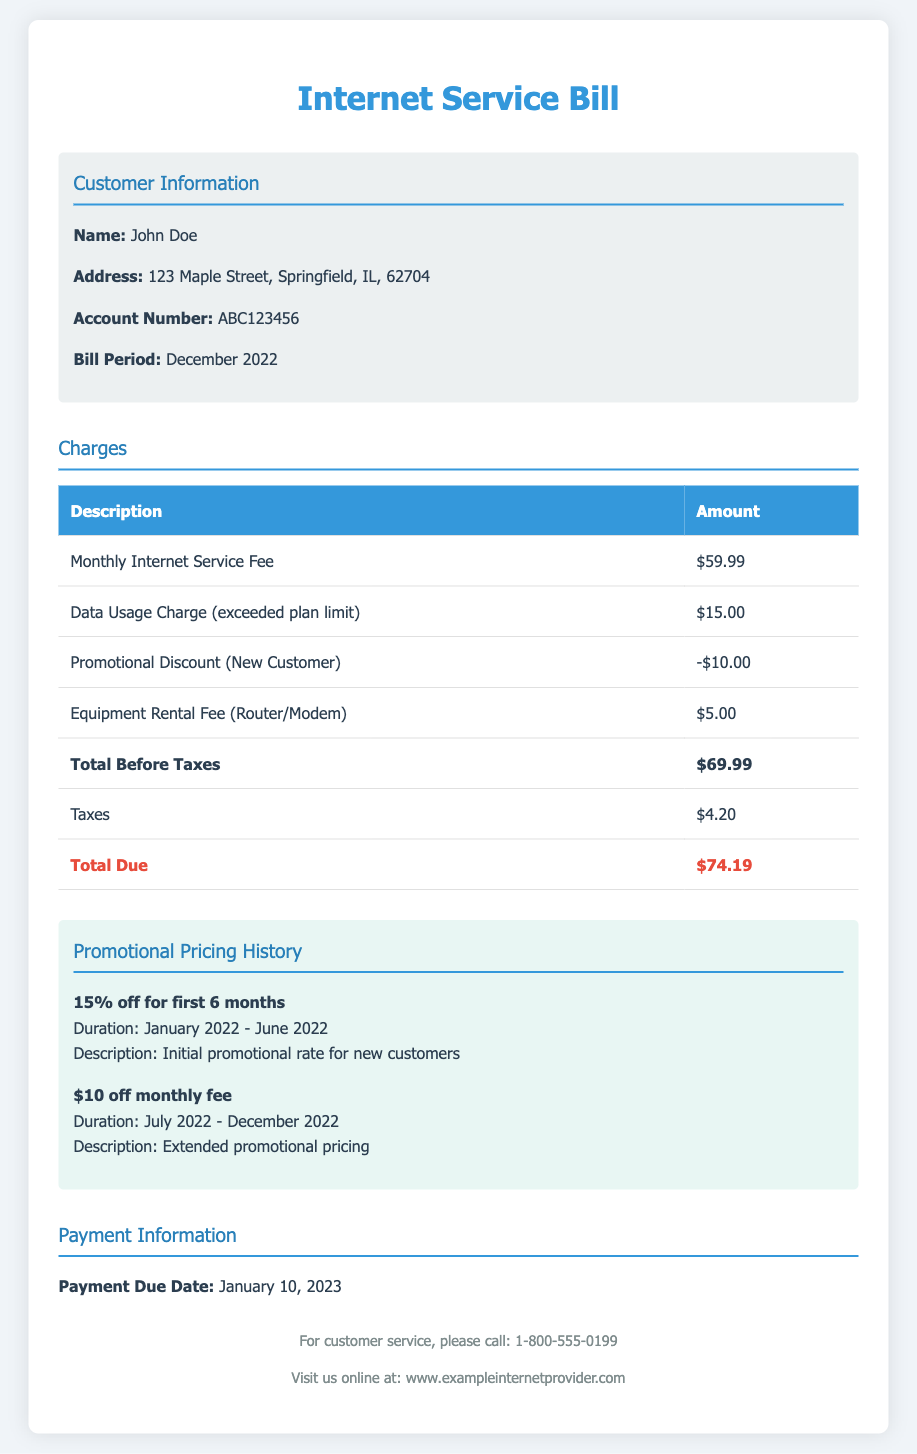What is the total due for the Internet service bill? The total due is mentioned in the charges section as the final amount to be paid.
Answer: $74.19 What was the data usage charge for December 2022? The data usage charge is a specific line item listed under the charges section.
Answer: $15.00 What is the account number of the customer? The account number is provided in the customer information section.
Answer: ABC123456 What date is the payment due? The payment due date is specifically mentioned in the payment information section.
Answer: January 10, 2023 What was the promotional discount for December 2022? The promotional discount is indicated as a negative amount under charges for that month.
Answer: -$10.00 What was the duration of the promotional pricing providing $10 off? The duration is outlined in the promotional pricing history section.
Answer: July 2022 - December 2022 What is the monthly Internet service fee? The monthly Internet service fee is noted as a charge in the document.
Answer: $59.99 What type of service fee is applied for router/modem rental? The fee type is described under the charges section regarding equipment.
Answer: Equipment Rental Fee What was the initial promotional rate discount for new customers? The initial promotional rate is detailed in the promotional pricing history section.
Answer: 15% off for first 6 months 